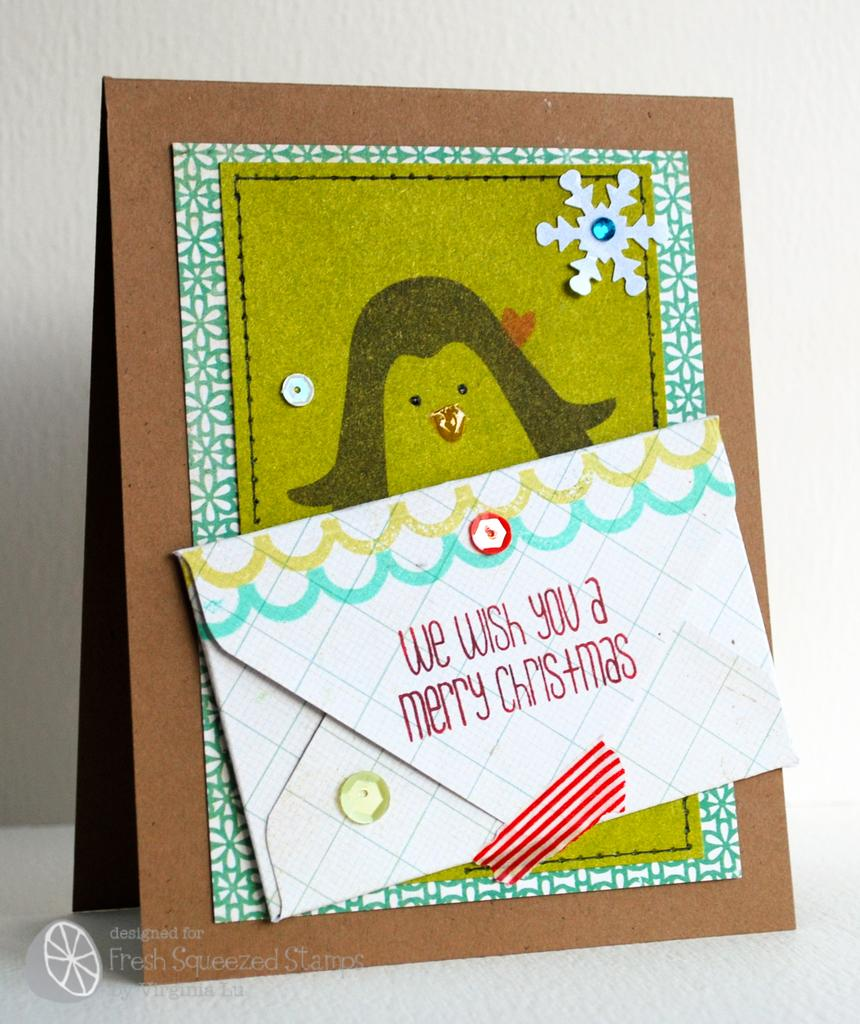<image>
Provide a brief description of the given image. A card and a envelope that says We wish you a Merry Christmas. 